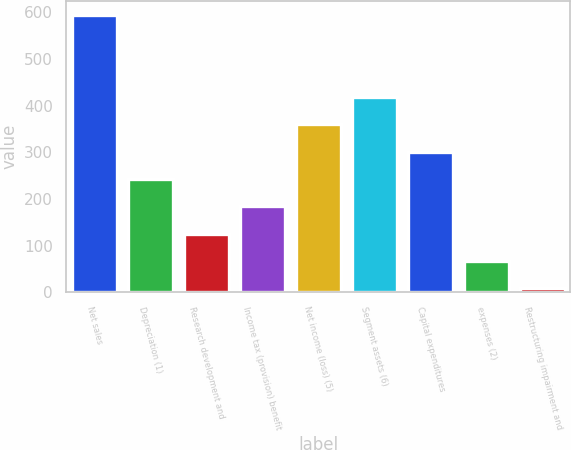<chart> <loc_0><loc_0><loc_500><loc_500><bar_chart><fcel>Net sales<fcel>Depreciation (1)<fcel>Research development and<fcel>Income tax (provision) benefit<fcel>Net income (loss) (5)<fcel>Segment assets (6)<fcel>Capital expenditures<fcel>expenses (2)<fcel>Restructuring impairment and<nl><fcel>595<fcel>242.8<fcel>125.4<fcel>184.1<fcel>360.2<fcel>418.9<fcel>301.5<fcel>66.7<fcel>8<nl></chart> 